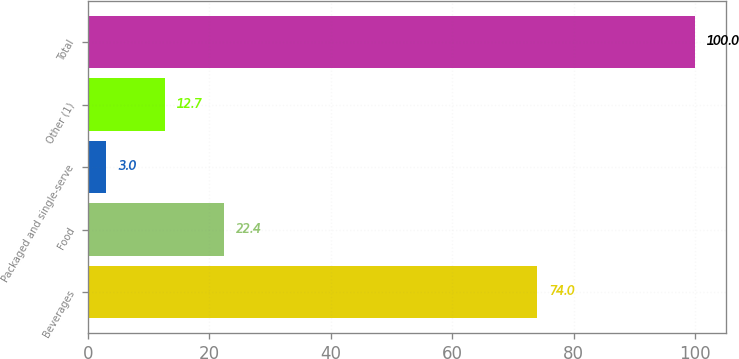Convert chart. <chart><loc_0><loc_0><loc_500><loc_500><bar_chart><fcel>Beverages<fcel>Food<fcel>Packaged and single-serve<fcel>Other (1)<fcel>Total<nl><fcel>74<fcel>22.4<fcel>3<fcel>12.7<fcel>100<nl></chart> 